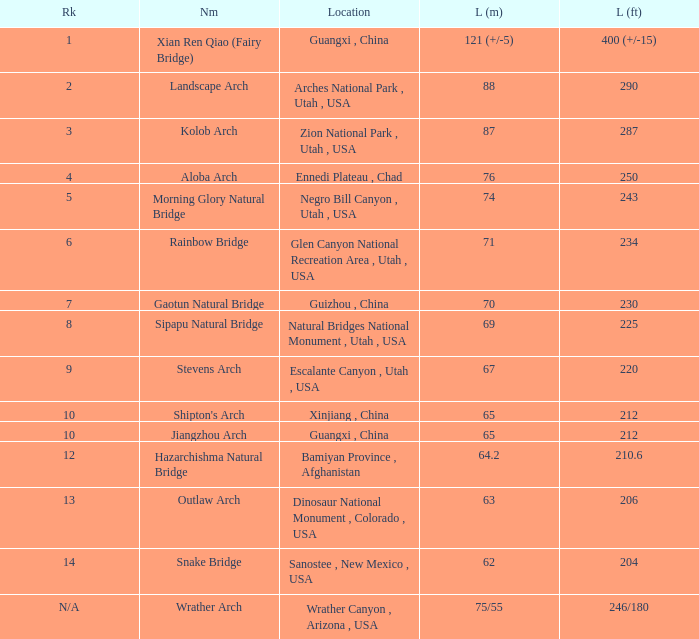2-meter-long arch be found? Bamiyan Province , Afghanistan. 